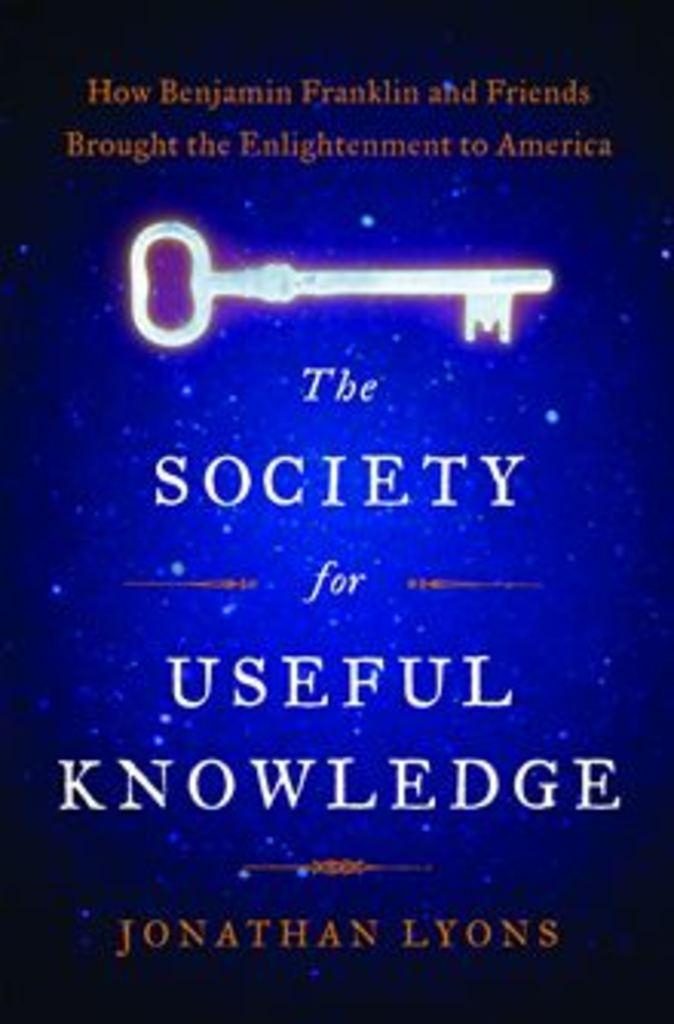<image>
Summarize the visual content of the image. A blue book called The Society for Useful Knowledge has a white key on the cover. 